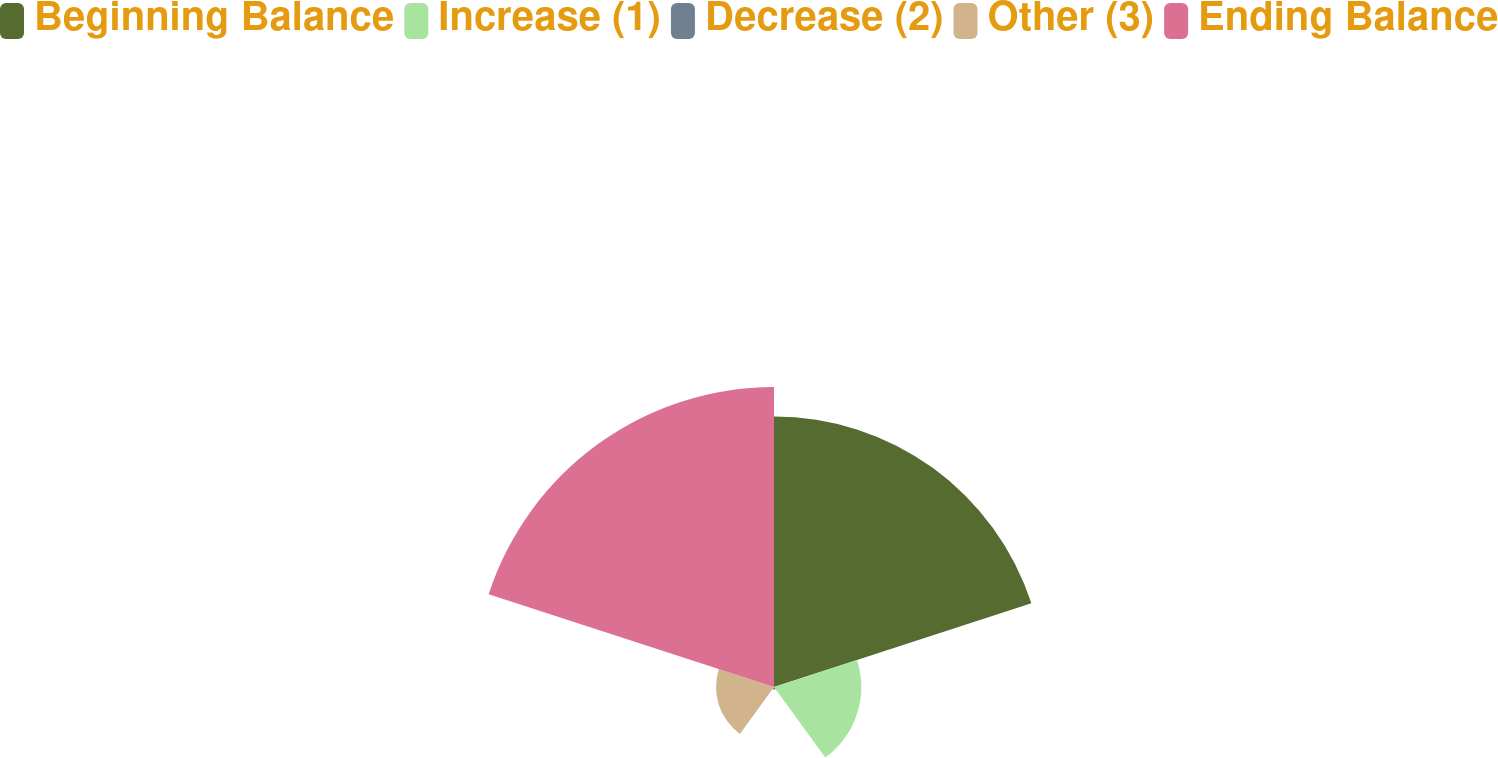Convert chart to OTSL. <chart><loc_0><loc_0><loc_500><loc_500><pie_chart><fcel>Beginning Balance<fcel>Increase (1)<fcel>Decrease (2)<fcel>Other (3)<fcel>Ending Balance<nl><fcel>37.67%<fcel>12.15%<fcel>0.35%<fcel>8.07%<fcel>41.76%<nl></chart> 